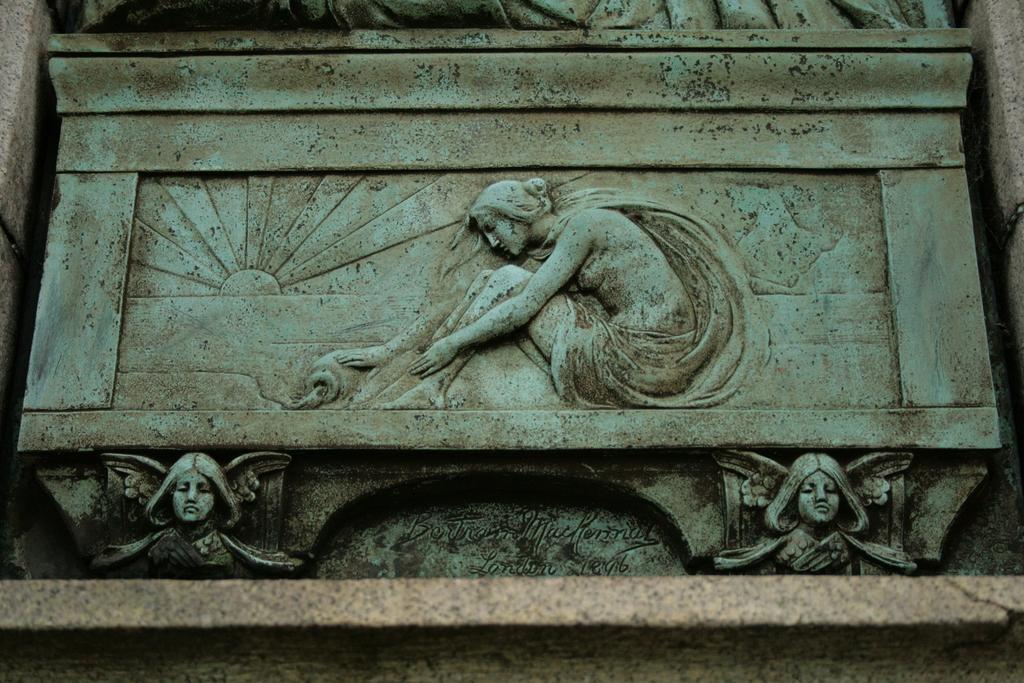Could you give a brief overview of what you see in this image? In this image we can see sculptures and text on the wall. 